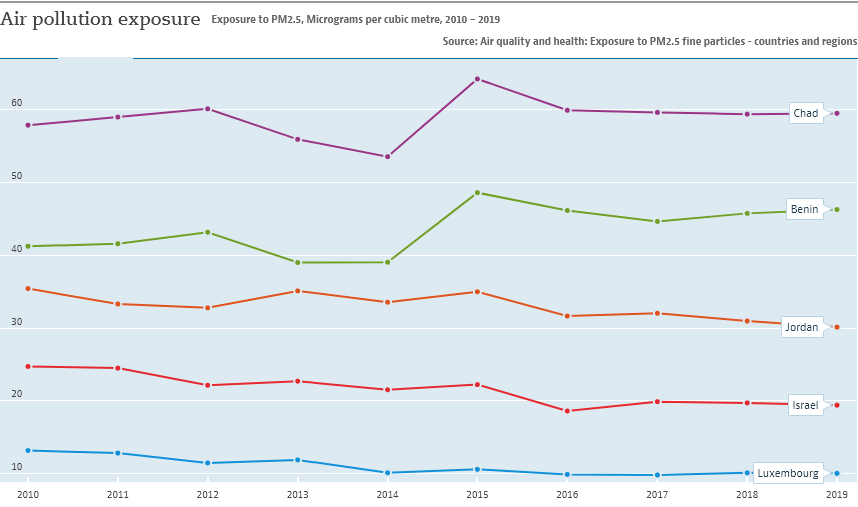Highlight a few significant elements in this photo. According to the data provided, 2 countries have Air pollution exposure rate of more than 40. In 2015, the line representing Chad saw its highest peak. 